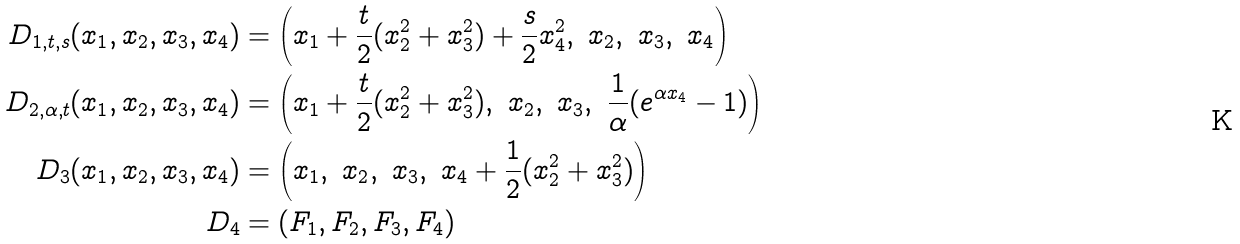Convert formula to latex. <formula><loc_0><loc_0><loc_500><loc_500>D _ { 1 , t , s } ( x _ { 1 } , x _ { 2 } , x _ { 3 } , x _ { 4 } ) & = \left ( x _ { 1 } + \frac { t } { 2 } ( x _ { 2 } ^ { 2 } + x _ { 3 } ^ { 2 } ) + \frac { s } { 2 } x _ { 4 } ^ { 2 } , \ x _ { 2 } , \ x _ { 3 } , \ x _ { 4 } \right ) \\ D _ { 2 , \alpha , t } ( x _ { 1 } , x _ { 2 } , x _ { 3 } , x _ { 4 } ) & = \left ( x _ { 1 } + \frac { t } { 2 } ( x _ { 2 } ^ { 2 } + x _ { 3 } ^ { 2 } ) , \ x _ { 2 } , \ x _ { 3 } , \ \frac { 1 } { \alpha } ( e ^ { \alpha x _ { 4 } } - 1 ) \right ) \\ D _ { 3 } ( x _ { 1 } , x _ { 2 } , x _ { 3 } , x _ { 4 } ) & = \left ( x _ { 1 } , \ x _ { 2 } , \ x _ { 3 } , \ x _ { 4 } + \frac { 1 } { 2 } ( x _ { 2 } ^ { 2 } + x _ { 3 } ^ { 2 } ) \right ) \\ D _ { 4 } & = ( F _ { 1 } , F _ { 2 } , F _ { 3 } , F _ { 4 } )</formula> 